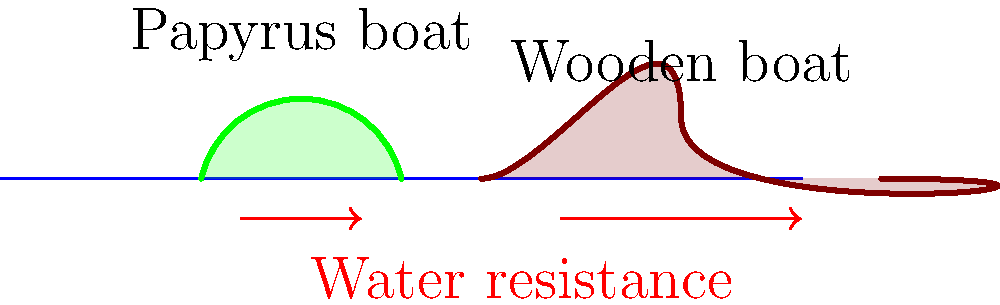Compare the mechanical efficiency of ancient Egyptian papyrus boats and wooden boats. Which design would likely have less water resistance and why? To understand the mechanical efficiency of ancient Egyptian boats, we need to consider their hull designs and how they interact with water:

1. Papyrus boats:
   - Made from bundled reeds
   - Typically had a curved, round-bottomed hull
   - Displaced less water due to lighter weight

2. Wooden boats:
   - Made from planks of wood
   - Usually had a flatter bottom and more angular hull shape
   - Heavier and displaced more water

3. Water resistance:
   - Depends on the boat's cross-sectional area in contact with water
   - Affected by the smoothness of the hull surface

4. Comparison:
   - Papyrus boats had a more streamlined shape
   - Their rounded bottom reduced water resistance
   - The lighter weight meant less water displacement

5. Hydrodynamics:
   - A more streamlined shape allows water to flow more easily around the hull
   - This reduces drag and increases efficiency

6. Material properties:
   - Papyrus is naturally water-resistant and creates a smoother surface
   - Wooden boats may have more irregular surfaces, increasing friction

Therefore, papyrus boats would likely have less water resistance due to their streamlined shape, lighter weight, and smoother surface, making them more mechanically efficient in calm waters.
Answer: Papyrus boats, due to streamlined shape and lighter weight. 